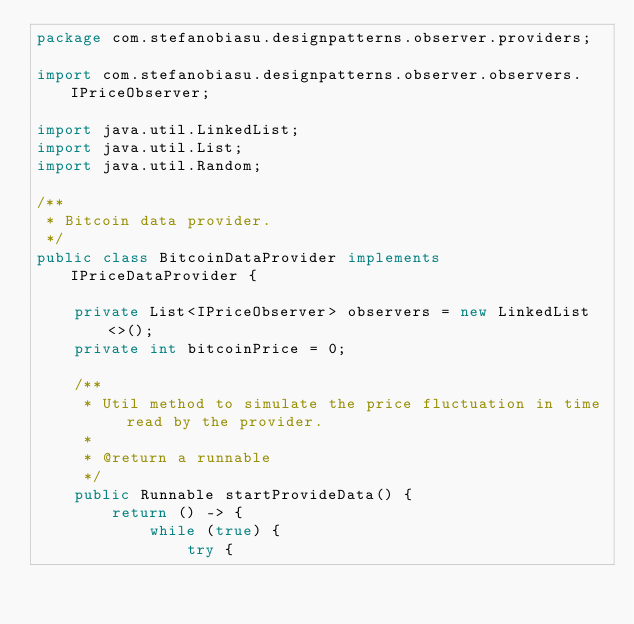Convert code to text. <code><loc_0><loc_0><loc_500><loc_500><_Java_>package com.stefanobiasu.designpatterns.observer.providers;

import com.stefanobiasu.designpatterns.observer.observers.IPriceObserver;

import java.util.LinkedList;
import java.util.List;
import java.util.Random;

/**
 * Bitcoin data provider.
 */
public class BitcoinDataProvider implements IPriceDataProvider {

    private List<IPriceObserver> observers = new LinkedList<>();
    private int bitcoinPrice = 0;

    /**
     * Util method to simulate the price fluctuation in time read by the provider.
     *
     * @return a runnable
     */
    public Runnable startProvideData() {
        return () -> {
            while (true) {
                try {</code> 